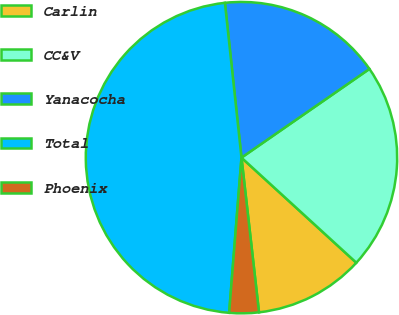Convert chart to OTSL. <chart><loc_0><loc_0><loc_500><loc_500><pie_chart><fcel>Carlin<fcel>CC&V<fcel>Yanacocha<fcel>Total<fcel>Phoenix<nl><fcel>11.41%<fcel>21.44%<fcel>17.05%<fcel>47.04%<fcel>3.06%<nl></chart> 